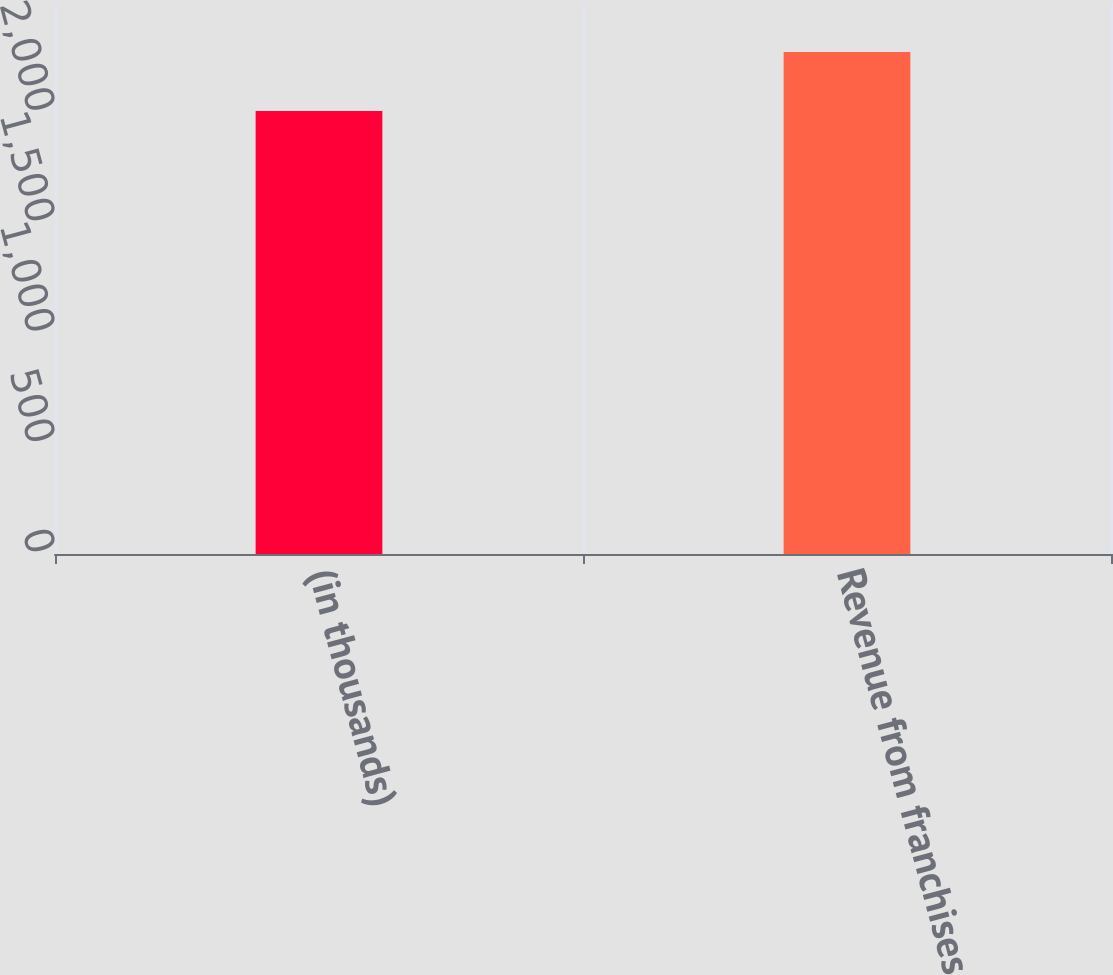Convert chart. <chart><loc_0><loc_0><loc_500><loc_500><bar_chart><fcel>(in thousands)<fcel>Revenue from franchises<nl><fcel>2006<fcel>2273<nl></chart> 